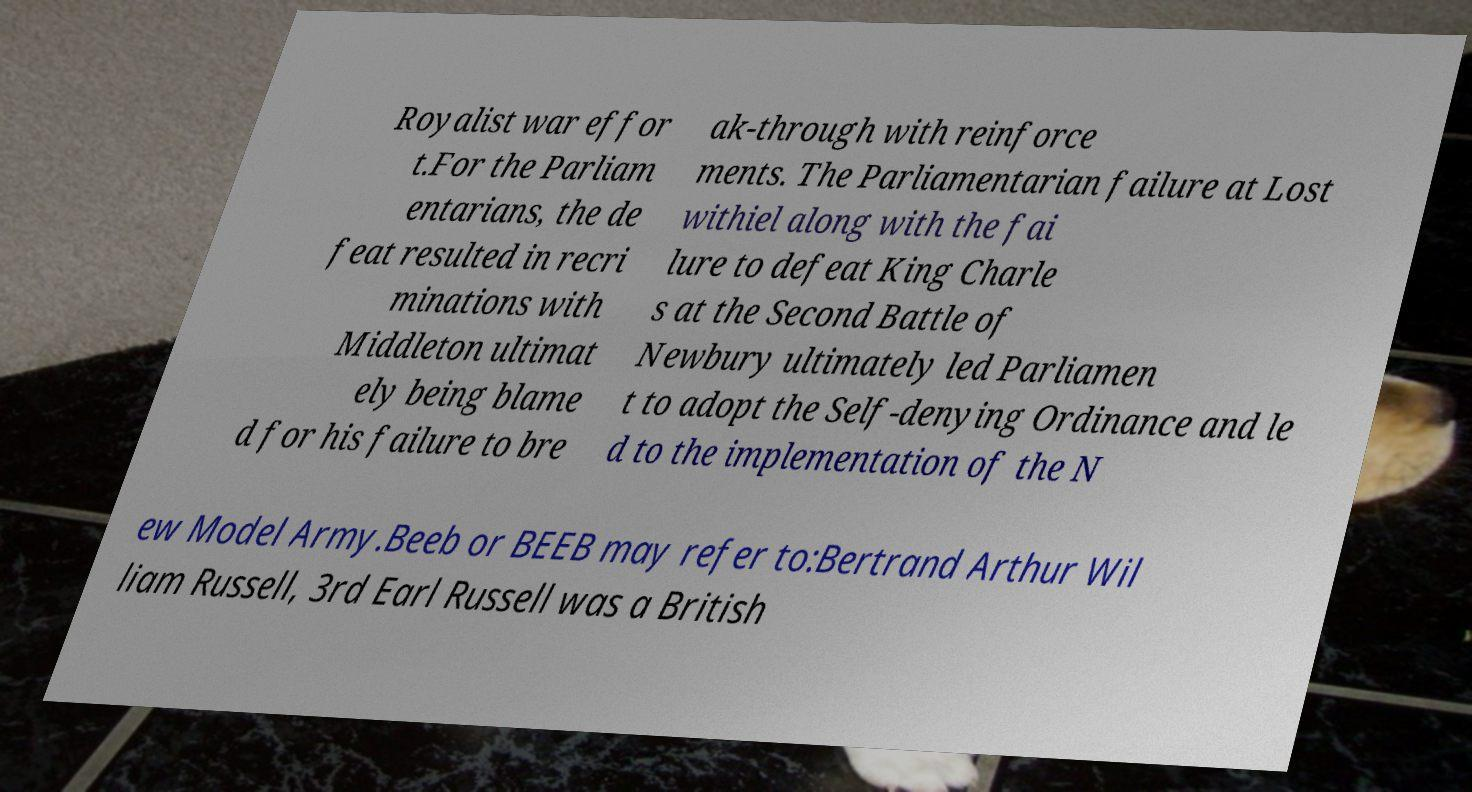Who is Bertrand Russell and why is he mentioned in the context of 'Beeb'? Bertrand Arthur William Russell, 3rd Earl Russell, was a renowned British philosopher, logician, and social critic, best known for his work in mathematical logic and moral philosophy. It appears that the text might be alluding to a nickname or acronym 'Beeb', possibly in some context unrelated directly to his scholarly work, maybe as a playful shorthand or in a distinctly different context, like broadcasting, where 'Beeb' is sometimes colloquially used to refer to the BBC. 